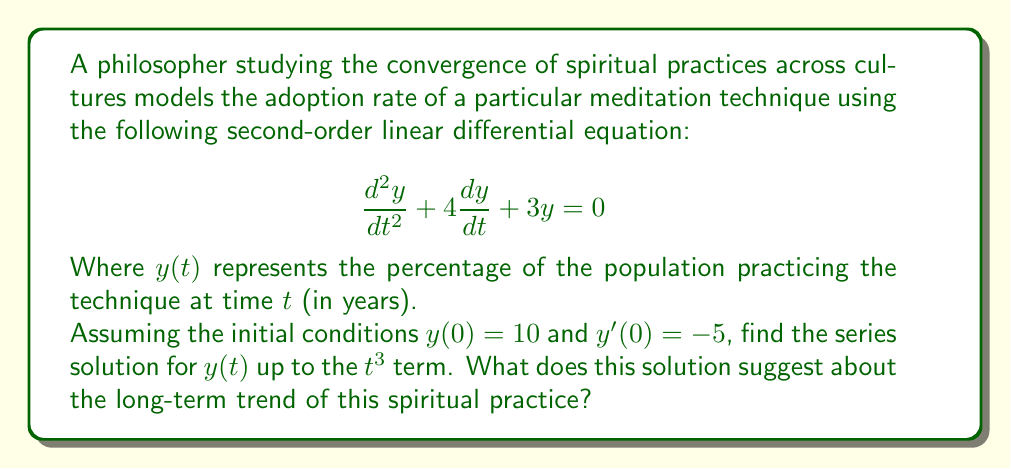Show me your answer to this math problem. To solve this problem, we'll use the method of series solutions for second-order linear differential equations.

Step 1: Assume a power series solution of the form:
$$y(t) = \sum_{n=0}^{\infty} a_n t^n = a_0 + a_1t + a_2t^2 + a_3t^3 + \cdots$$

Step 2: Differentiate the series:
$$y'(t) = \sum_{n=1}^{\infty} na_n t^{n-1} = a_1 + 2a_2t + 3a_3t^2 + \cdots$$
$$y''(t) = \sum_{n=2}^{\infty} n(n-1)a_n t^{n-2} = 2a_2 + 6a_3t + 12a_4t^2 + \cdots$$

Step 3: Substitute these into the differential equation:
$$(2a_2 + 6a_3t + 12a_4t^2 + \cdots) + 4(a_1 + 2a_2t + 3a_3t^2 + \cdots) + 3(a_0 + a_1t + a_2t^2 + a_3t^3 + \cdots) = 0$$

Step 4: Collect like terms and set coefficients to zero:
$$(2a_2 + 4a_1 + 3a_0) + (6a_3 + 8a_2 + 3a_1)t + (12a_4 + 12a_3 + 3a_2)t^2 + \cdots = 0$$

Step 5: Solve for the coefficients:
$2a_2 + 4a_1 + 3a_0 = 0$
$6a_3 + 8a_2 + 3a_1 = 0$
$12a_4 + 12a_3 + 3a_2 = 0$

Step 6: Use the initial conditions to find $a_0$ and $a_1$:
$y(0) = a_0 = 10$
$y'(0) = a_1 = -5$

Step 7: Solve for $a_2$ using the first equation:
$2a_2 + 4(-5) + 3(10) = 0$
$2a_2 = 20 - 30 = -10$
$a_2 = -5$

Step 8: Solve for $a_3$ using the second equation:
$6a_3 + 8(-5) + 3(-5) = 0$
$6a_3 = 55$
$a_3 = \frac{55}{6}$

Step 9: Write the series solution up to the $t^3$ term:
$$y(t) = 10 - 5t - 5t^2 + \frac{55}{6}t^3 + \cdots$$

Interpretation: The series solution suggests that the adoption of the spiritual practice initially decreases (negative linear term), but then begins to increase again (positive cubic term). This could indicate an initial decline in popularity followed by a resurgence of interest in the long term.
Answer: $y(t) = 10 - 5t - 5t^2 + \frac{55}{6}t^3 + O(t^4)$ 